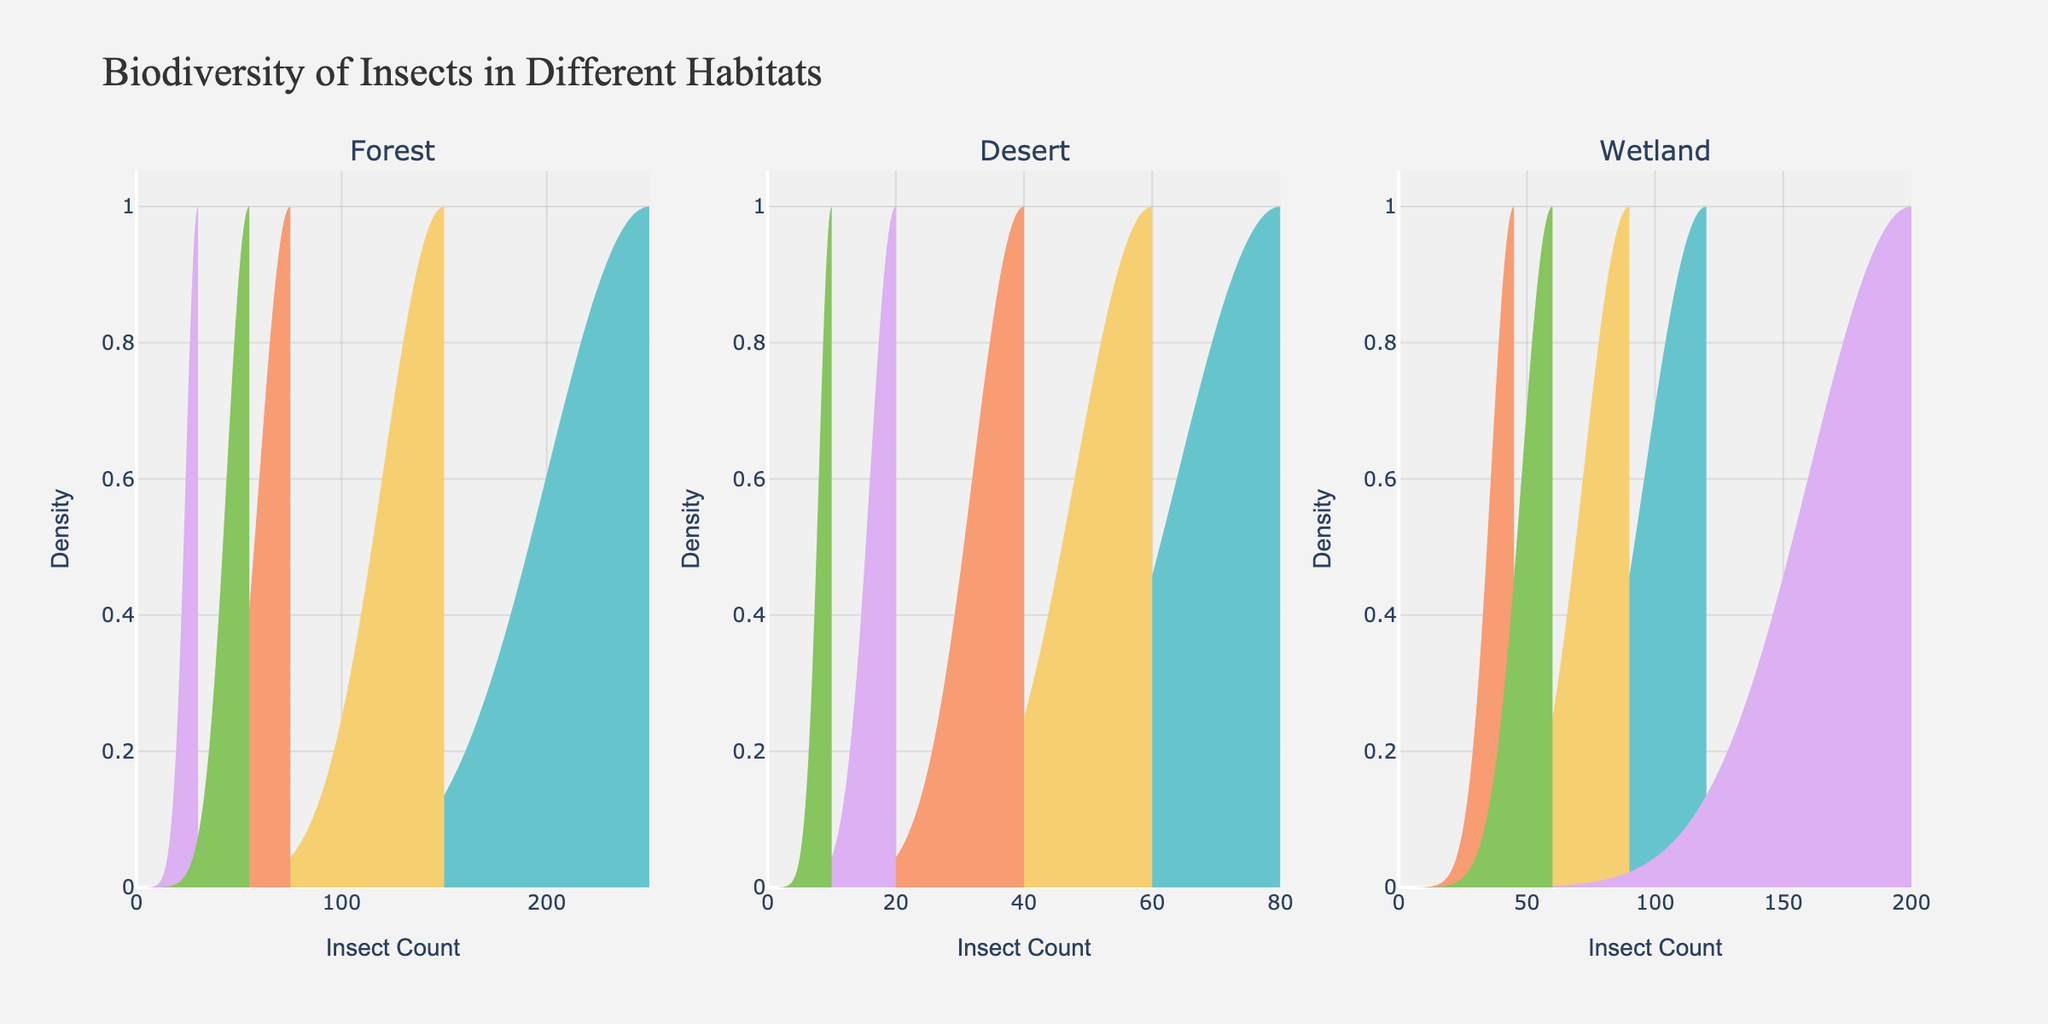What are the habitats being compared in the figure? The title of the figure and the labels in the subplots indicate that the habitats are "Forest," "Desert," and "Wetland."
Answer: Forest, Desert, Wetland Which species has the highest insect count in the forest? In the forest subplot, the species with the highest density plot peak is Ants, which suggests the highest insect count.
Answer: Ants How do the insect counts of beetles compare between the forest and the desert? The density plot for beetles in the forest shows a peak at 150, while in the desert, the beetle density plot peaks at 60. This means beetle counts are higher in the forest.
Answer: Higher in the forest Which species has the widest density distribution in the wetland? The mosquito density plot in the wetland subplot spreads out the most horizontally, indicating the widest distribution.
Answer: Mosquito What is the order of species based on insect count in the desert? By looking at the peaks of the density plots in the desert subplot: Ant (80), Beetle (60), Moth (40), Cicada (20), Scorpion (10). This means ants have the highest count, followed by beetles, moths, cicadas, and scorpions.
Answer: Ant, Beetle, Moth, Cicada, Scorpion Which habitat has the highest count for dragonflies? The peak of the dragonfly density plot in the wetland subplot is 120, compared to the forest with 30. There is no dragonfly data for the desert.
Answer: Wetland How does the density of butterflies compare between forest and wetland? In the forest subplot, the butterfly density plot peaks at 75, while in the wetland subplot, it peaks at 45, indicating butterflies are more populous in the forest.
Answer: More populous in the forest What can you infer about the diversity of insect species between the habitats? By counting the unique species depicted in the density plots for each habitat: Forest has 5 species, Desert has 5, Wetland has 5. Although the number of species is the same, the counts and distributions differ.
Answer: Similar diversity, different distributions What do the density plots suggest about the population distribution of ants in the forest compared to the desert? The density plot for ants in the forest shows a higher peak (250) compared to the desert (80), suggesting ants are much more populous in the forest.
Answer: More populous in the forest 